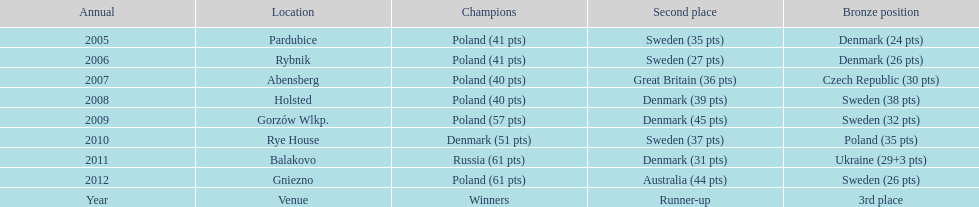Previous to 2008 how many times was sweden the runner up? 2. 